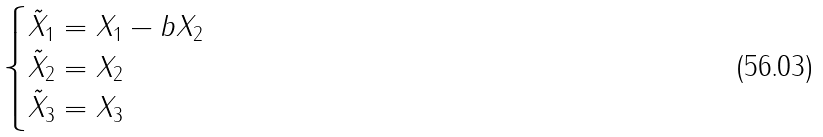Convert formula to latex. <formula><loc_0><loc_0><loc_500><loc_500>\begin{cases} \tilde { X } _ { 1 } = X _ { 1 } - b X _ { 2 } \\ \tilde { X } _ { 2 } = X _ { 2 } \\ \tilde { X } _ { 3 } = X _ { 3 } \end{cases}</formula> 